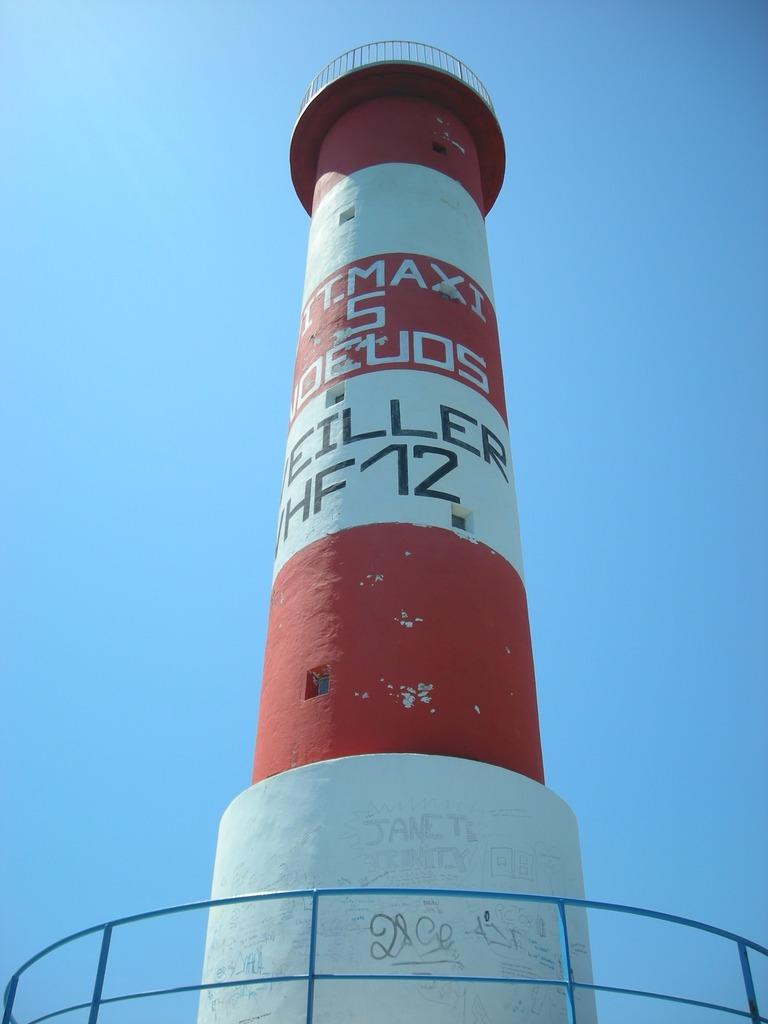What is the main structure in the image? There is a lighthouse in the image. What can be seen in the background of the image? The sky is visible in the background of the image. What type of sense can be seen on the top of the lighthouse in the image? There is no sense present on the top of the lighthouse in the image. How many waves are crashing against the lighthouse in the image? There are no waves present in the image; it only features a lighthouse and the sky. 